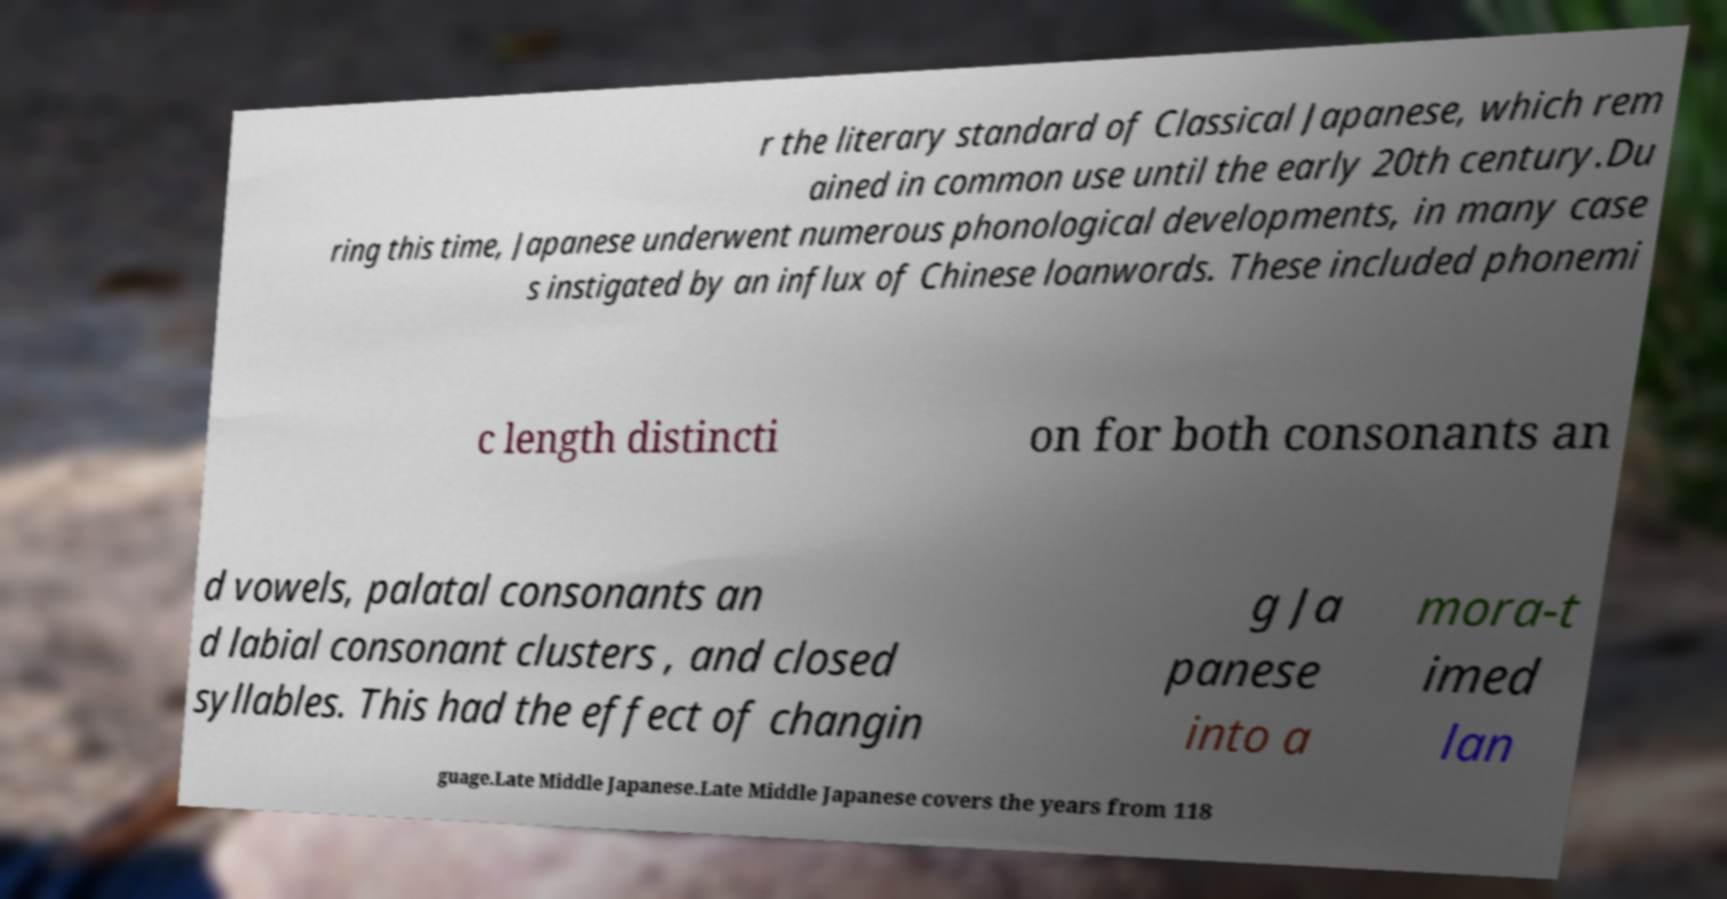Please read and relay the text visible in this image. What does it say? r the literary standard of Classical Japanese, which rem ained in common use until the early 20th century.Du ring this time, Japanese underwent numerous phonological developments, in many case s instigated by an influx of Chinese loanwords. These included phonemi c length distincti on for both consonants an d vowels, palatal consonants an d labial consonant clusters , and closed syllables. This had the effect of changin g Ja panese into a mora-t imed lan guage.Late Middle Japanese.Late Middle Japanese covers the years from 118 